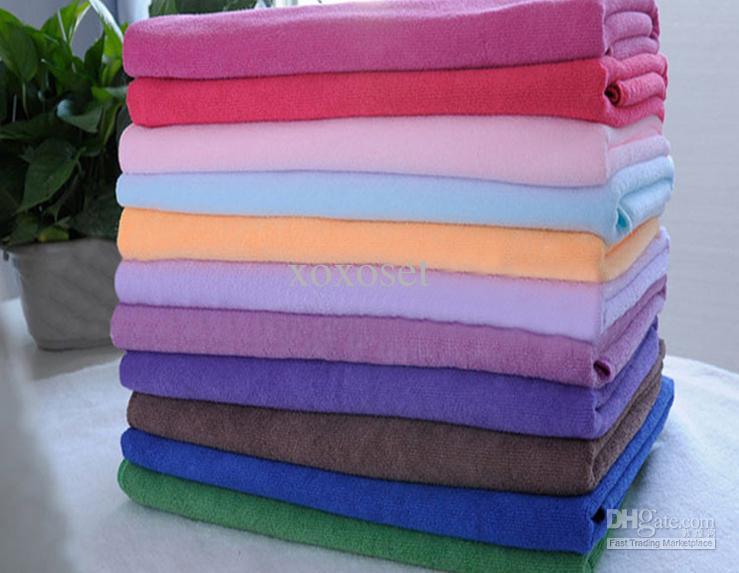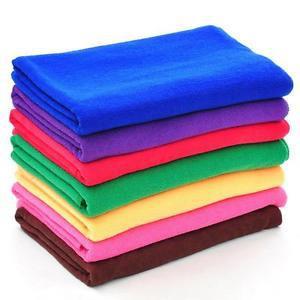The first image is the image on the left, the second image is the image on the right. Considering the images on both sides, is "In one image, exactly five different colored towels, which are folded with edges to the inside, have been placed in a stack." valid? Answer yes or no. No. The first image is the image on the left, the second image is the image on the right. For the images displayed, is the sentence "One image features exactly five folded towels in primarily blue and brown shades." factually correct? Answer yes or no. No. 